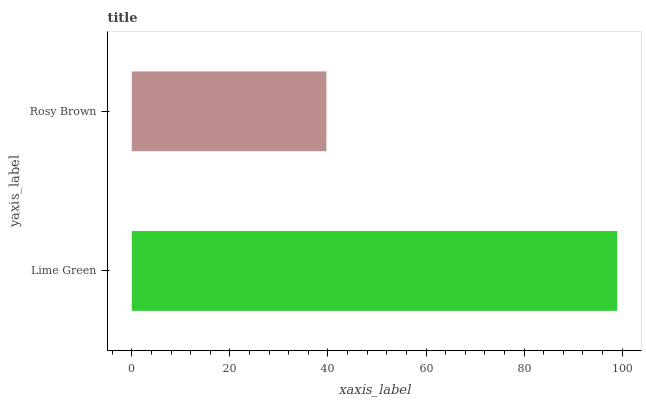Is Rosy Brown the minimum?
Answer yes or no. Yes. Is Lime Green the maximum?
Answer yes or no. Yes. Is Rosy Brown the maximum?
Answer yes or no. No. Is Lime Green greater than Rosy Brown?
Answer yes or no. Yes. Is Rosy Brown less than Lime Green?
Answer yes or no. Yes. Is Rosy Brown greater than Lime Green?
Answer yes or no. No. Is Lime Green less than Rosy Brown?
Answer yes or no. No. Is Lime Green the high median?
Answer yes or no. Yes. Is Rosy Brown the low median?
Answer yes or no. Yes. Is Rosy Brown the high median?
Answer yes or no. No. Is Lime Green the low median?
Answer yes or no. No. 